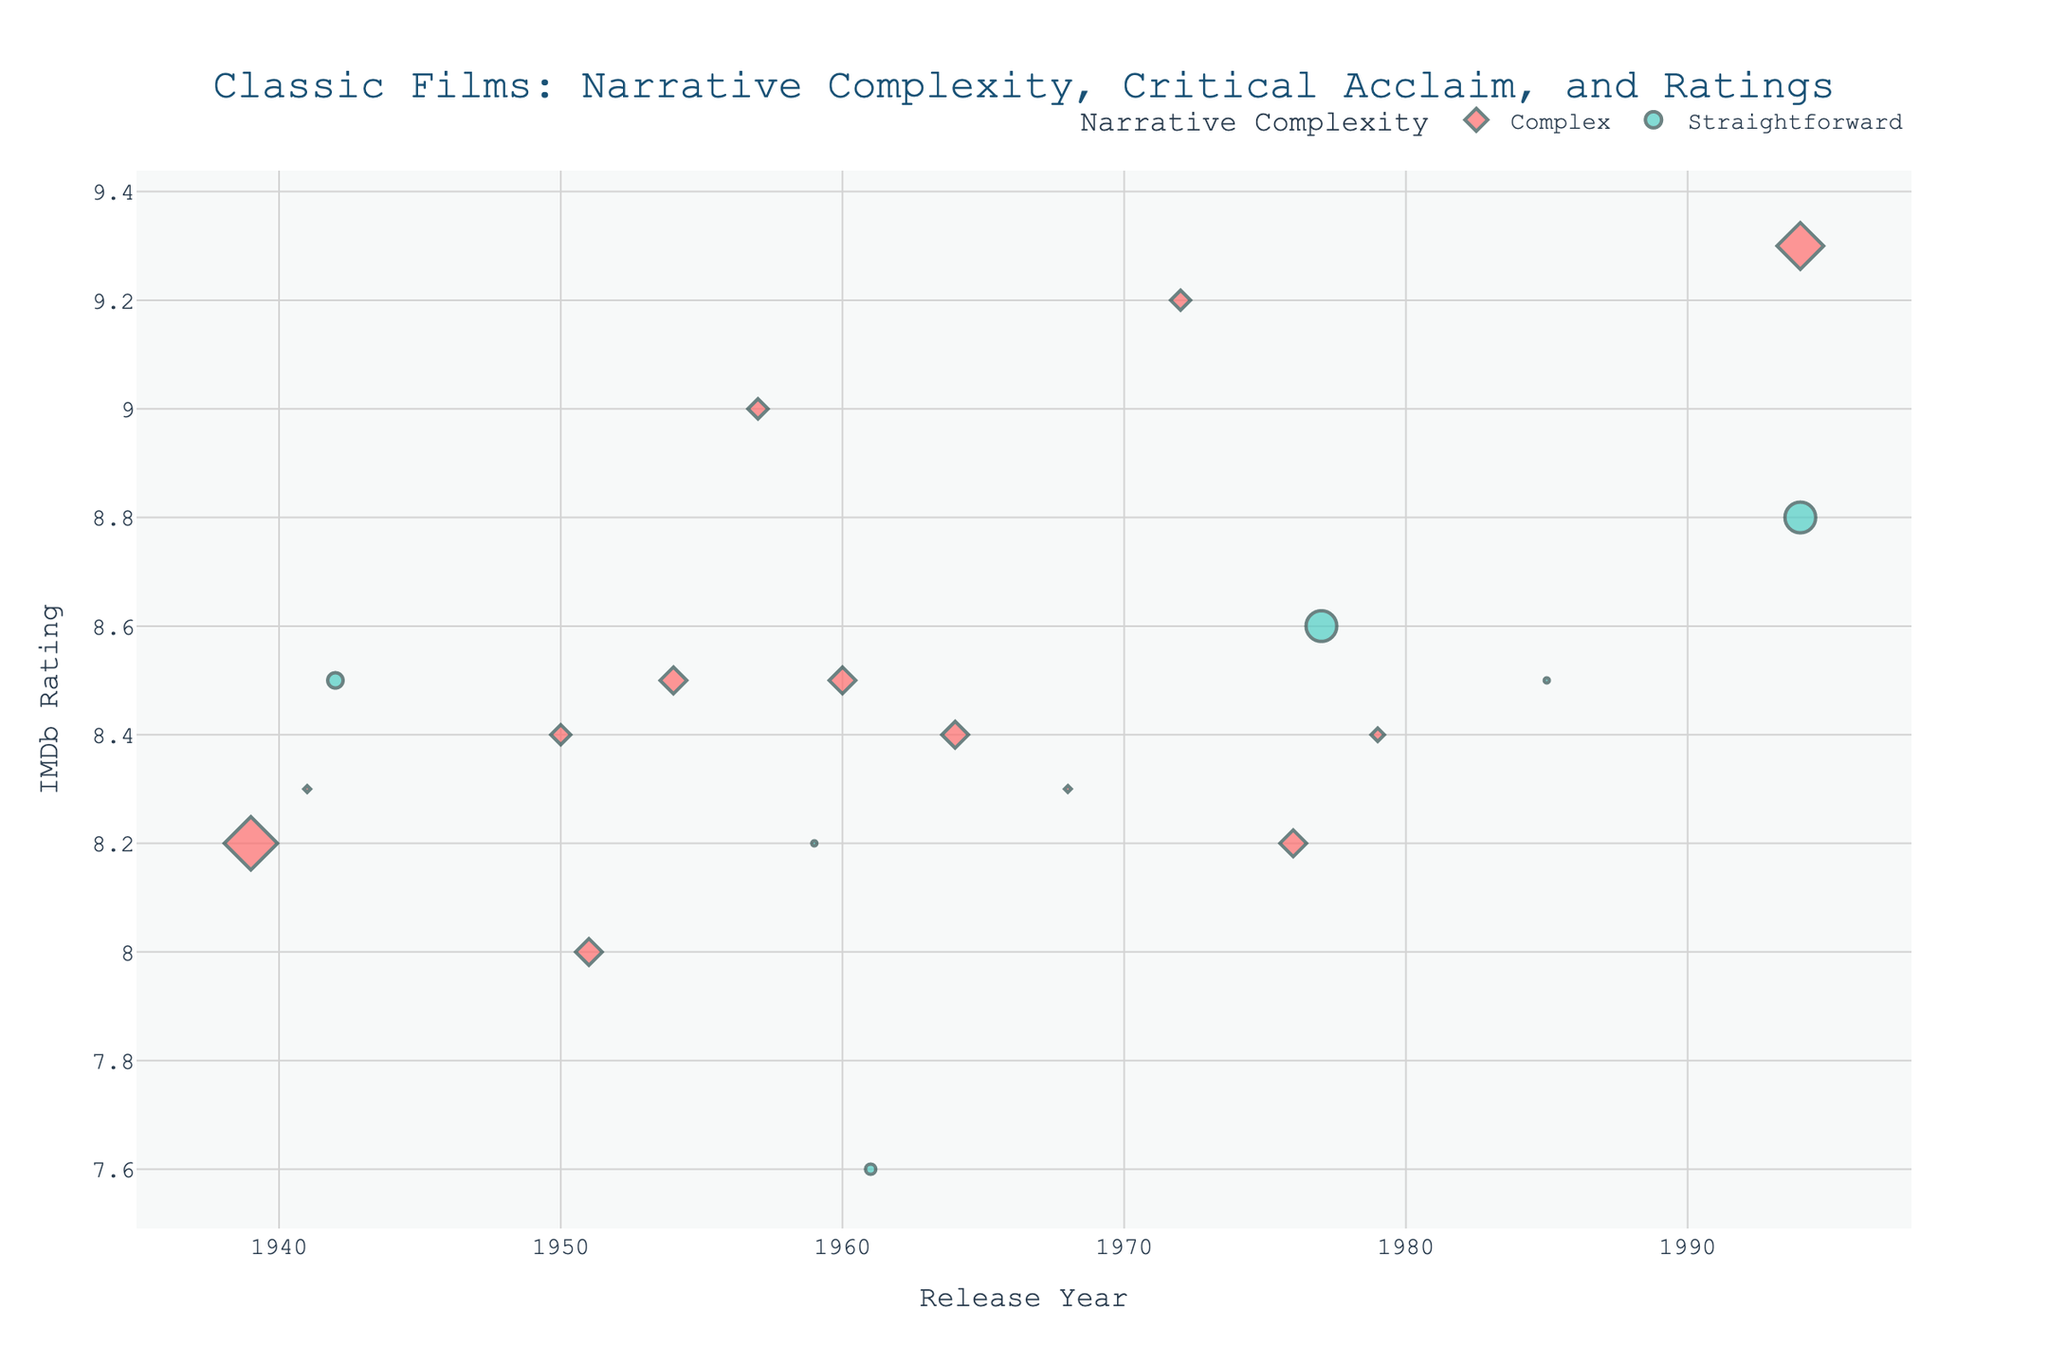What's the title of the figure? The title of the figure is prominently displayed at the top. By reading it, we can directly determine the title.
Answer: Classic Films: Narrative Complexity, Critical Acclaim, and Ratings How does the scatter plot differentiate between complex and straightforward narratives? The scatter plot uses different shapes and colors to differentiate between complex and straightforward narratives. Complex narratives use diamond shapes and a specific color, while straightforward narratives use circle shapes and a different specific color.
Answer: By shape and color In which release year are the most awards represented by complex narrative films? By examining the size of the markers (representing awards) and noting the release years, we can compare which year has the largest markers for complex narrative films.
Answer: 1939 What is the IMDb rating of "Forrest Gump" and how many awards did it win? We can locate the data point for "Forrest Gump" from the hover information or the scatter plot. It shows the rating and the size of the marker which represents the awards won.
Answer: IMDb Rating: 8.8, Awards: 6 Compare the average IMDb rating for complex narrative films to that of straightforward narrative films. To find the average, sum up the IMDb ratings for each group separately and divide by the number of films in each group. For complex: (9.0 + 9.2 + 8.2 + 8.5 + 8.4 + 8.3 + 8.3 + 8.5 + 9.3 + 8.2 + 8.4 + 8.4 + 8.0 + 8.4) / 14 and for straightforward: (8.5 + 8.2 + 8.6 + 7.6 + 8.8 + 8.5) / 6
Answer: Complex: 8.571, Straightforward: 8.367 Which film with a complex narrative has the lowest IMDb rating? To determine this, we compare the IMDb ratings of all the complex narrative films and identify the film with the lowest rating.
Answer: A Streetcar Named Desire (8.0) How do films released in the 1990s compare in terms of awards with those released in the 1940s? We analyze the markers' sizes for both decades by comparing the 1990s films "The Shawshank Redemption" and "Forrest Gump" to the 1940s films "Casablanca" and "Citizen Kane".
Answer: 1990s: 13 awards, 1940s: 4 awards Which straightforward narrative film has the highest IMDb rating, and what is that rating? By examining the IMDb ratings for all straightforward narrative films shown in the scatter plot and identifying the highest one.
Answer: Forrest Gump, 8.8 Is there a correlation between the release year and IMDb rating for complex narrative films? By observing the scatter plot for complex narrative films, we look for any discernible trend or pattern between the release year on the x-axis and IMDb rating on the y-axis. Calculation is done by noting visible trends.
Answer: No clear correlation 